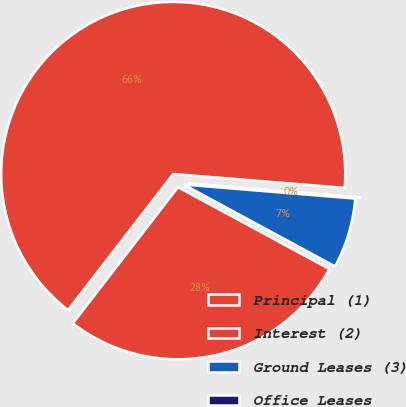<chart> <loc_0><loc_0><loc_500><loc_500><pie_chart><fcel>Principal (1)<fcel>Interest (2)<fcel>Ground Leases (3)<fcel>Office Leases<nl><fcel>65.83%<fcel>27.58%<fcel>6.59%<fcel>0.01%<nl></chart> 